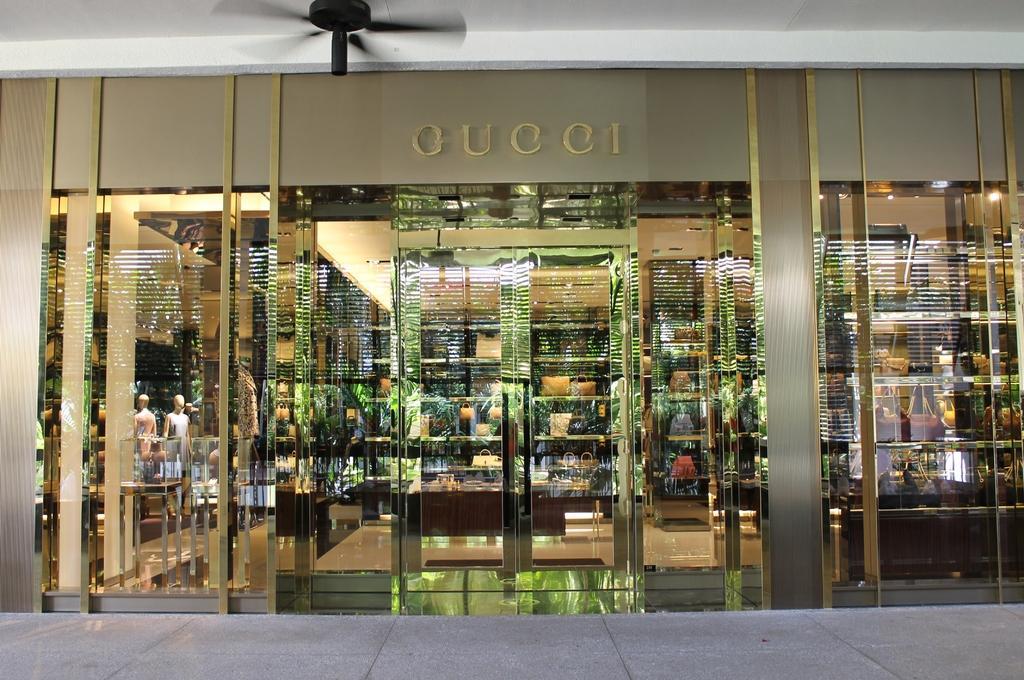In one or two sentences, can you explain what this image depicts? In this image I can see a building with some text written on it. At the top I can see a fan. 